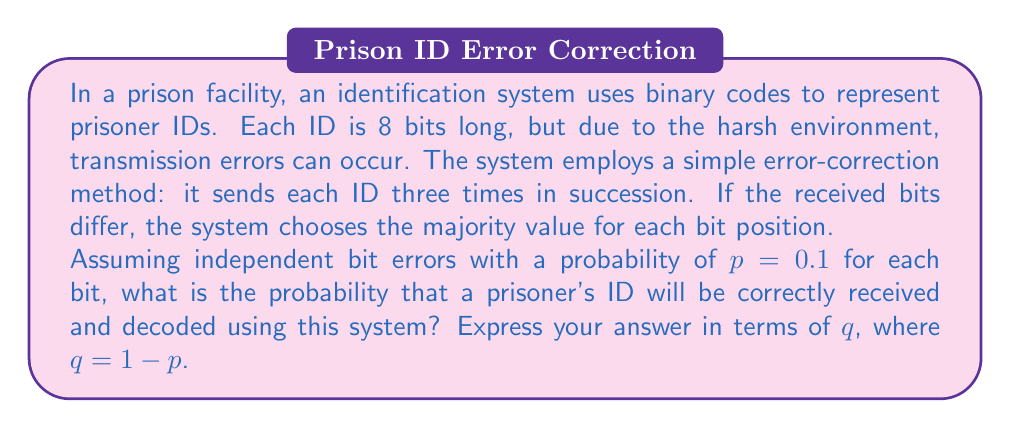Give your solution to this math problem. Let's approach this step-by-step:

1) For each bit position, we need at least 2 out of 3 transmissions to be correct for the majority decision to be correct.

2) The probability of a single bit being transmitted correctly is $q = 1-p = 0.9$.

3) For each bit position, there are four possible scenarios:
   - All 3 transmissions are correct: probability $q^3$
   - 2 are correct and 1 is incorrect: probability $3q^2p$ (there are 3 ways to choose which 2 are correct)

4) The probability of a correct decision for a single bit is thus:
   $P(\text{correct bit}) = q^3 + 3q^2p = q^3 + 3q^2(1-q) = q^3 + 3q^2 - 3q^3 = 3q^2 - 2q^3$

5) For the entire 8-bit ID to be correct, all 8 bits must be correctly decided. Since the errors are independent, we multiply these probabilities:

   $P(\text{correct ID}) = (3q^2 - 2q^3)^8$

6) Substituting $q = 0.9$:

   $P(\text{correct ID}) = (3(0.9)^2 - 2(0.9)^3)^8$
                         $= (2.43 - 1.458)^8$
                         $= 0.972^8$
                         $\approx 0.7941$

Therefore, the probability of correctly receiving and decoding a prisoner's ID is approximately 0.7941 or about 79.41%.
Answer: $(3q^2 - 2q^3)^8 \approx 0.7941$ 